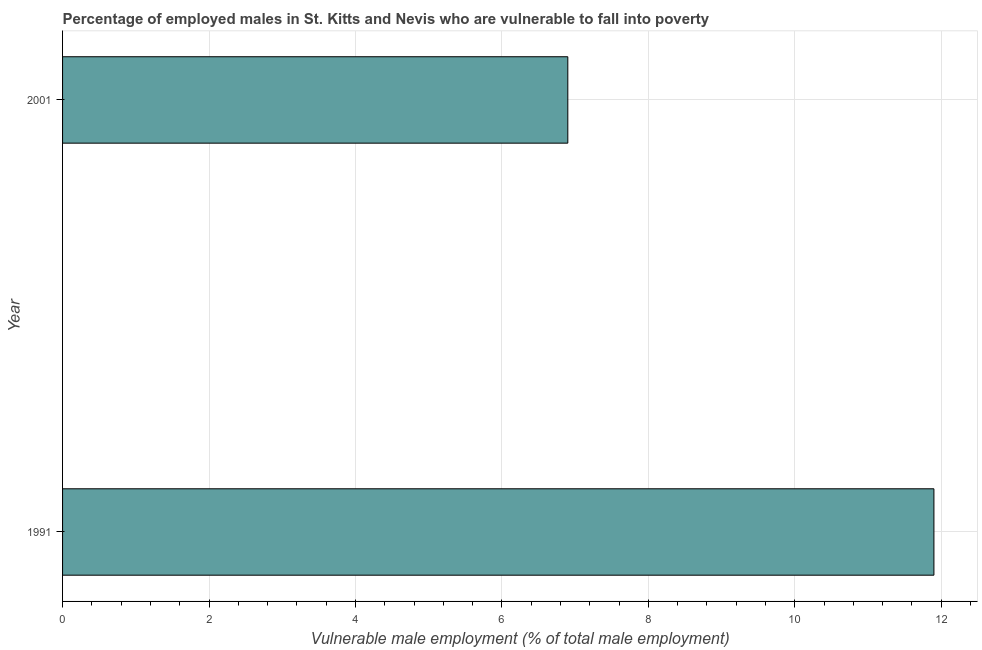What is the title of the graph?
Make the answer very short. Percentage of employed males in St. Kitts and Nevis who are vulnerable to fall into poverty. What is the label or title of the X-axis?
Your answer should be very brief. Vulnerable male employment (% of total male employment). What is the percentage of employed males who are vulnerable to fall into poverty in 1991?
Your answer should be very brief. 11.9. Across all years, what is the maximum percentage of employed males who are vulnerable to fall into poverty?
Make the answer very short. 11.9. Across all years, what is the minimum percentage of employed males who are vulnerable to fall into poverty?
Offer a terse response. 6.9. What is the sum of the percentage of employed males who are vulnerable to fall into poverty?
Your answer should be compact. 18.8. What is the average percentage of employed males who are vulnerable to fall into poverty per year?
Offer a terse response. 9.4. What is the median percentage of employed males who are vulnerable to fall into poverty?
Keep it short and to the point. 9.4. In how many years, is the percentage of employed males who are vulnerable to fall into poverty greater than 0.4 %?
Your answer should be very brief. 2. What is the ratio of the percentage of employed males who are vulnerable to fall into poverty in 1991 to that in 2001?
Ensure brevity in your answer.  1.73. In how many years, is the percentage of employed males who are vulnerable to fall into poverty greater than the average percentage of employed males who are vulnerable to fall into poverty taken over all years?
Keep it short and to the point. 1. How many bars are there?
Your answer should be compact. 2. What is the Vulnerable male employment (% of total male employment) of 1991?
Provide a succinct answer. 11.9. What is the Vulnerable male employment (% of total male employment) in 2001?
Provide a short and direct response. 6.9. What is the difference between the Vulnerable male employment (% of total male employment) in 1991 and 2001?
Provide a short and direct response. 5. What is the ratio of the Vulnerable male employment (% of total male employment) in 1991 to that in 2001?
Your answer should be very brief. 1.73. 